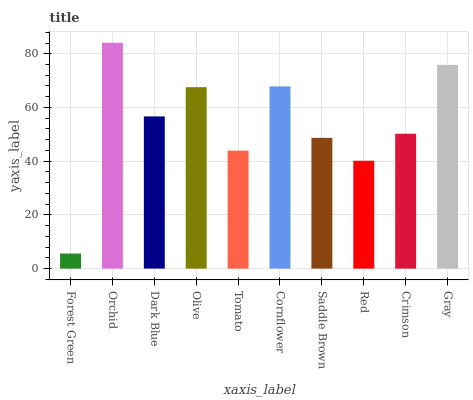Is Forest Green the minimum?
Answer yes or no. Yes. Is Orchid the maximum?
Answer yes or no. Yes. Is Dark Blue the minimum?
Answer yes or no. No. Is Dark Blue the maximum?
Answer yes or no. No. Is Orchid greater than Dark Blue?
Answer yes or no. Yes. Is Dark Blue less than Orchid?
Answer yes or no. Yes. Is Dark Blue greater than Orchid?
Answer yes or no. No. Is Orchid less than Dark Blue?
Answer yes or no. No. Is Dark Blue the high median?
Answer yes or no. Yes. Is Crimson the low median?
Answer yes or no. Yes. Is Forest Green the high median?
Answer yes or no. No. Is Dark Blue the low median?
Answer yes or no. No. 